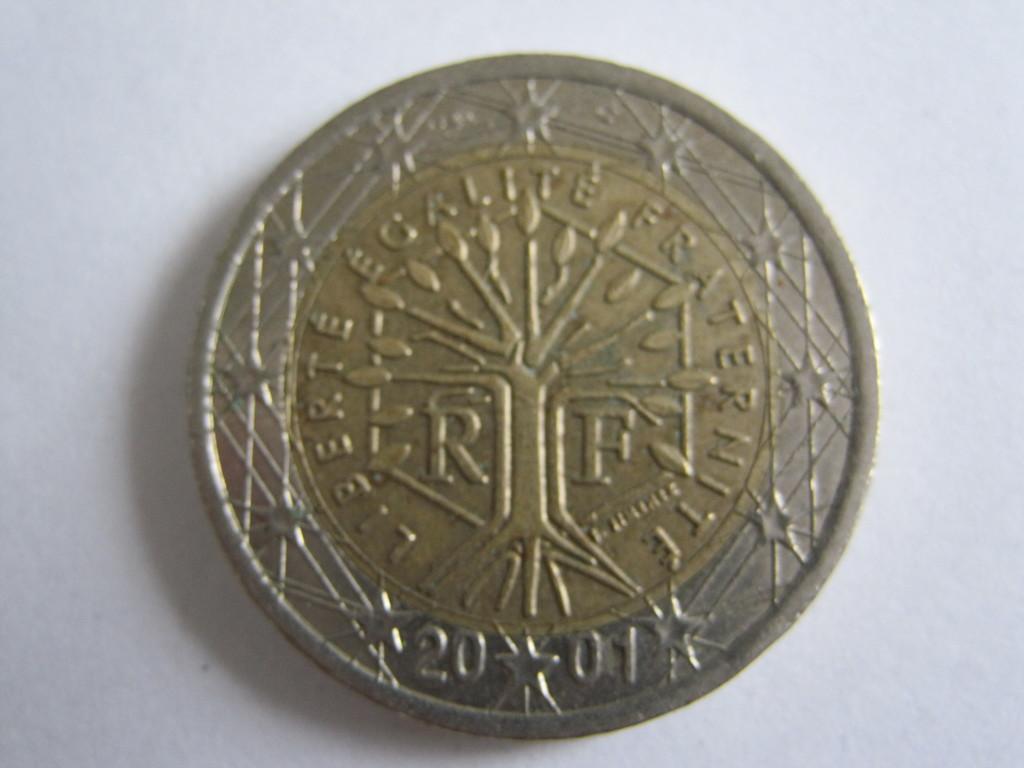Can you describe this image briefly? In this image I can see a coin and I can see white color background. 